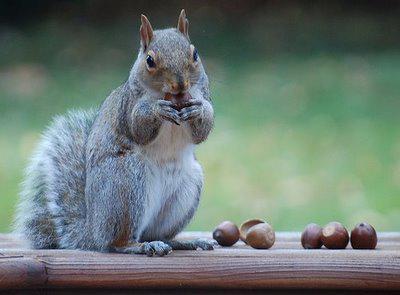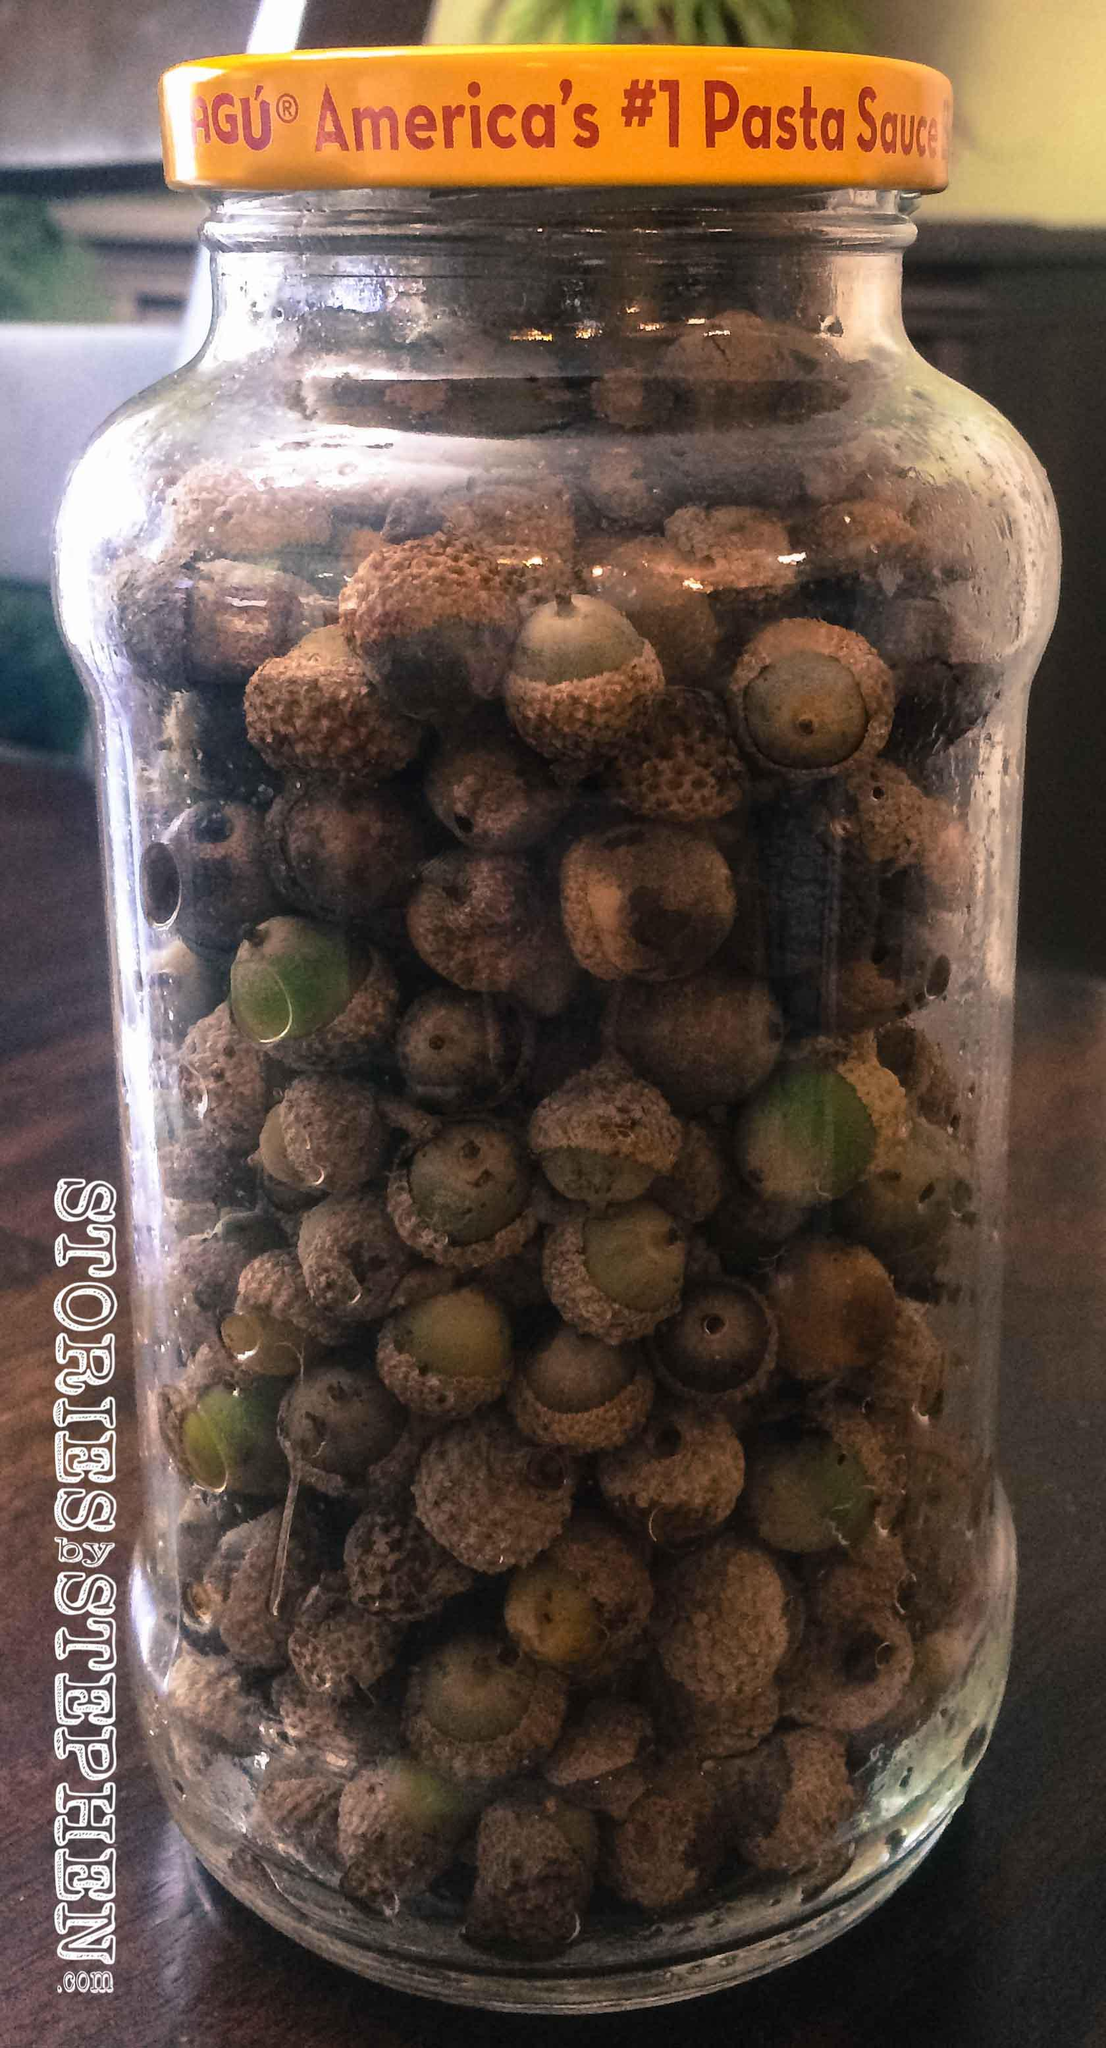The first image is the image on the left, the second image is the image on the right. For the images displayed, is the sentence "In at least one  image there is a cracked acorn sitting on dirt and leaves on the ground." factually correct? Answer yes or no. No. The first image is the image on the left, the second image is the image on the right. For the images shown, is this caption "The acorns are lying on the ground." true? Answer yes or no. No. 